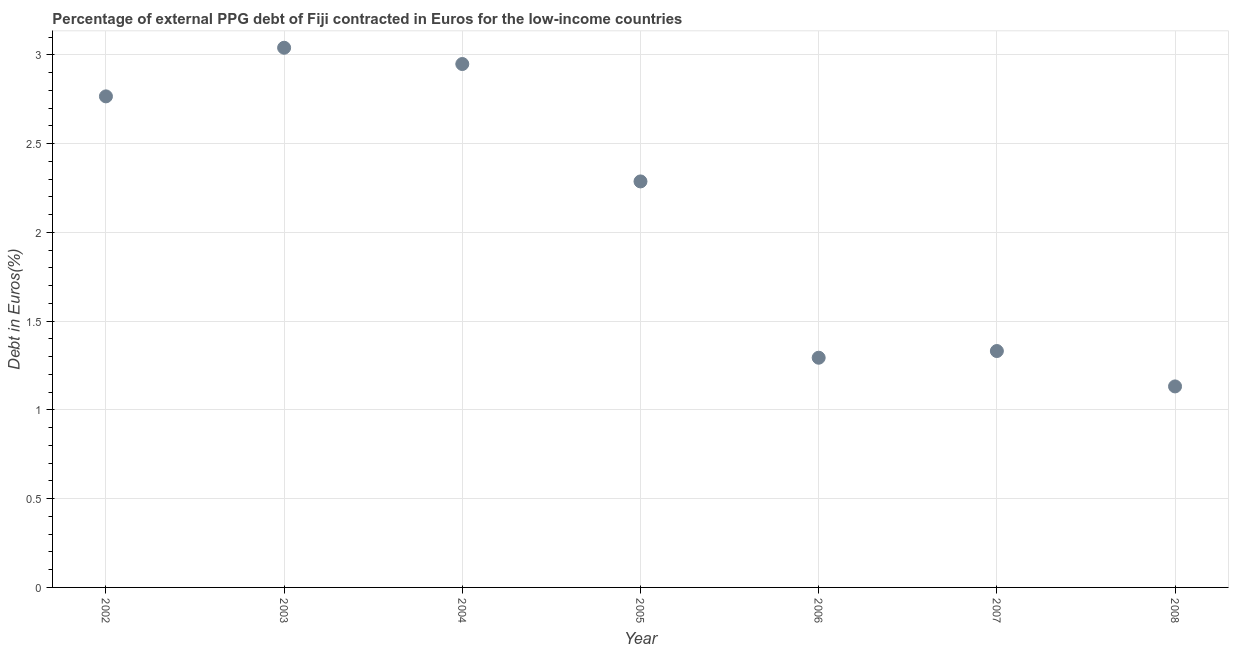What is the currency composition of ppg debt in 2004?
Provide a succinct answer. 2.95. Across all years, what is the maximum currency composition of ppg debt?
Offer a terse response. 3.04. Across all years, what is the minimum currency composition of ppg debt?
Provide a succinct answer. 1.13. In which year was the currency composition of ppg debt maximum?
Your answer should be very brief. 2003. What is the sum of the currency composition of ppg debt?
Your answer should be compact. 14.8. What is the difference between the currency composition of ppg debt in 2003 and 2007?
Your response must be concise. 1.71. What is the average currency composition of ppg debt per year?
Your response must be concise. 2.11. What is the median currency composition of ppg debt?
Offer a very short reply. 2.29. Do a majority of the years between 2003 and 2004 (inclusive) have currency composition of ppg debt greater than 0.5 %?
Offer a terse response. Yes. What is the ratio of the currency composition of ppg debt in 2003 to that in 2005?
Give a very brief answer. 1.33. Is the currency composition of ppg debt in 2005 less than that in 2006?
Make the answer very short. No. What is the difference between the highest and the second highest currency composition of ppg debt?
Keep it short and to the point. 0.09. What is the difference between the highest and the lowest currency composition of ppg debt?
Your answer should be very brief. 1.91. In how many years, is the currency composition of ppg debt greater than the average currency composition of ppg debt taken over all years?
Make the answer very short. 4. Does the currency composition of ppg debt monotonically increase over the years?
Your response must be concise. No. How many dotlines are there?
Your response must be concise. 1. How many years are there in the graph?
Provide a succinct answer. 7. What is the difference between two consecutive major ticks on the Y-axis?
Make the answer very short. 0.5. Does the graph contain grids?
Give a very brief answer. Yes. What is the title of the graph?
Give a very brief answer. Percentage of external PPG debt of Fiji contracted in Euros for the low-income countries. What is the label or title of the X-axis?
Make the answer very short. Year. What is the label or title of the Y-axis?
Make the answer very short. Debt in Euros(%). What is the Debt in Euros(%) in 2002?
Your answer should be very brief. 2.77. What is the Debt in Euros(%) in 2003?
Give a very brief answer. 3.04. What is the Debt in Euros(%) in 2004?
Provide a succinct answer. 2.95. What is the Debt in Euros(%) in 2005?
Provide a short and direct response. 2.29. What is the Debt in Euros(%) in 2006?
Your response must be concise. 1.29. What is the Debt in Euros(%) in 2007?
Provide a short and direct response. 1.33. What is the Debt in Euros(%) in 2008?
Your answer should be compact. 1.13. What is the difference between the Debt in Euros(%) in 2002 and 2003?
Make the answer very short. -0.27. What is the difference between the Debt in Euros(%) in 2002 and 2004?
Offer a very short reply. -0.18. What is the difference between the Debt in Euros(%) in 2002 and 2005?
Give a very brief answer. 0.48. What is the difference between the Debt in Euros(%) in 2002 and 2006?
Your answer should be very brief. 1.47. What is the difference between the Debt in Euros(%) in 2002 and 2007?
Keep it short and to the point. 1.43. What is the difference between the Debt in Euros(%) in 2002 and 2008?
Your answer should be very brief. 1.63. What is the difference between the Debt in Euros(%) in 2003 and 2004?
Make the answer very short. 0.09. What is the difference between the Debt in Euros(%) in 2003 and 2005?
Keep it short and to the point. 0.75. What is the difference between the Debt in Euros(%) in 2003 and 2006?
Make the answer very short. 1.75. What is the difference between the Debt in Euros(%) in 2003 and 2007?
Give a very brief answer. 1.71. What is the difference between the Debt in Euros(%) in 2003 and 2008?
Provide a succinct answer. 1.91. What is the difference between the Debt in Euros(%) in 2004 and 2005?
Your response must be concise. 0.66. What is the difference between the Debt in Euros(%) in 2004 and 2006?
Provide a short and direct response. 1.65. What is the difference between the Debt in Euros(%) in 2004 and 2007?
Offer a terse response. 1.62. What is the difference between the Debt in Euros(%) in 2004 and 2008?
Give a very brief answer. 1.82. What is the difference between the Debt in Euros(%) in 2005 and 2007?
Provide a succinct answer. 0.96. What is the difference between the Debt in Euros(%) in 2005 and 2008?
Keep it short and to the point. 1.16. What is the difference between the Debt in Euros(%) in 2006 and 2007?
Your answer should be compact. -0.04. What is the difference between the Debt in Euros(%) in 2006 and 2008?
Make the answer very short. 0.16. What is the difference between the Debt in Euros(%) in 2007 and 2008?
Give a very brief answer. 0.2. What is the ratio of the Debt in Euros(%) in 2002 to that in 2003?
Your answer should be compact. 0.91. What is the ratio of the Debt in Euros(%) in 2002 to that in 2004?
Your answer should be compact. 0.94. What is the ratio of the Debt in Euros(%) in 2002 to that in 2005?
Provide a succinct answer. 1.21. What is the ratio of the Debt in Euros(%) in 2002 to that in 2006?
Ensure brevity in your answer.  2.14. What is the ratio of the Debt in Euros(%) in 2002 to that in 2007?
Offer a terse response. 2.08. What is the ratio of the Debt in Euros(%) in 2002 to that in 2008?
Keep it short and to the point. 2.44. What is the ratio of the Debt in Euros(%) in 2003 to that in 2004?
Offer a very short reply. 1.03. What is the ratio of the Debt in Euros(%) in 2003 to that in 2005?
Offer a very short reply. 1.33. What is the ratio of the Debt in Euros(%) in 2003 to that in 2006?
Your answer should be compact. 2.35. What is the ratio of the Debt in Euros(%) in 2003 to that in 2007?
Offer a very short reply. 2.28. What is the ratio of the Debt in Euros(%) in 2003 to that in 2008?
Your answer should be compact. 2.69. What is the ratio of the Debt in Euros(%) in 2004 to that in 2005?
Offer a very short reply. 1.29. What is the ratio of the Debt in Euros(%) in 2004 to that in 2006?
Make the answer very short. 2.28. What is the ratio of the Debt in Euros(%) in 2004 to that in 2007?
Make the answer very short. 2.21. What is the ratio of the Debt in Euros(%) in 2004 to that in 2008?
Keep it short and to the point. 2.6. What is the ratio of the Debt in Euros(%) in 2005 to that in 2006?
Your answer should be compact. 1.77. What is the ratio of the Debt in Euros(%) in 2005 to that in 2007?
Offer a very short reply. 1.72. What is the ratio of the Debt in Euros(%) in 2005 to that in 2008?
Make the answer very short. 2.02. What is the ratio of the Debt in Euros(%) in 2006 to that in 2007?
Offer a very short reply. 0.97. What is the ratio of the Debt in Euros(%) in 2006 to that in 2008?
Offer a very short reply. 1.14. What is the ratio of the Debt in Euros(%) in 2007 to that in 2008?
Provide a short and direct response. 1.18. 